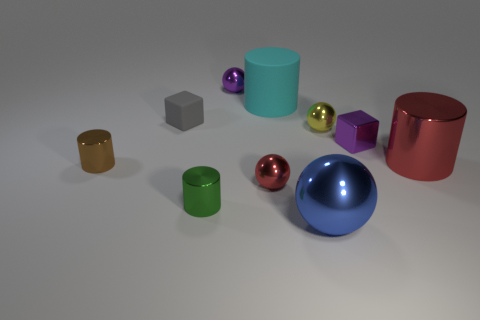Subtract all cyan cylinders. How many cylinders are left? 3 Subtract all red cylinders. How many cylinders are left? 3 Subtract all balls. How many objects are left? 6 Subtract all small purple shiny things. Subtract all gray cubes. How many objects are left? 7 Add 4 yellow metal things. How many yellow metal things are left? 5 Add 7 purple blocks. How many purple blocks exist? 8 Subtract 1 gray cubes. How many objects are left? 9 Subtract 1 blocks. How many blocks are left? 1 Subtract all brown spheres. Subtract all blue cylinders. How many spheres are left? 4 Subtract all green spheres. How many gray cubes are left? 1 